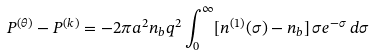<formula> <loc_0><loc_0><loc_500><loc_500>P ^ { ( \theta ) } - P ^ { ( k ) } = - 2 \pi a ^ { 2 } n _ { b } q ^ { 2 } \int _ { 0 } ^ { \infty } [ n ^ { ( 1 ) } ( \sigma ) - n _ { b } ] \, \sigma e ^ { - \sigma } \, d \sigma</formula> 